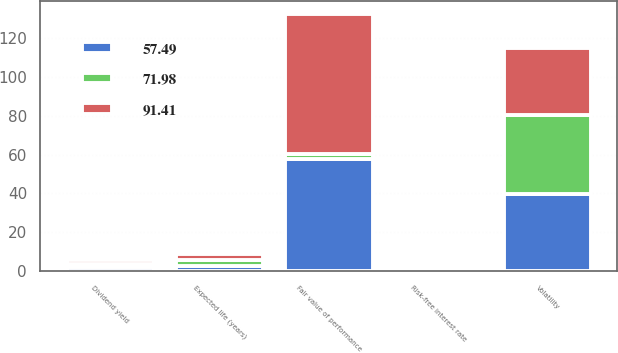Convert chart. <chart><loc_0><loc_0><loc_500><loc_500><stacked_bar_chart><ecel><fcel>Risk-free interest rate<fcel>Dividend yield<fcel>Expected life (years)<fcel>Volatility<fcel>Fair value of performance<nl><fcel>91.41<fcel>0.37<fcel>2.03<fcel>2.9<fcel>34.1<fcel>71.98<nl><fcel>71.98<fcel>1.34<fcel>1.61<fcel>2.9<fcel>40.48<fcel>2.9<nl><fcel>57.49<fcel>1.37<fcel>2.38<fcel>2.9<fcel>39.98<fcel>57.49<nl></chart> 